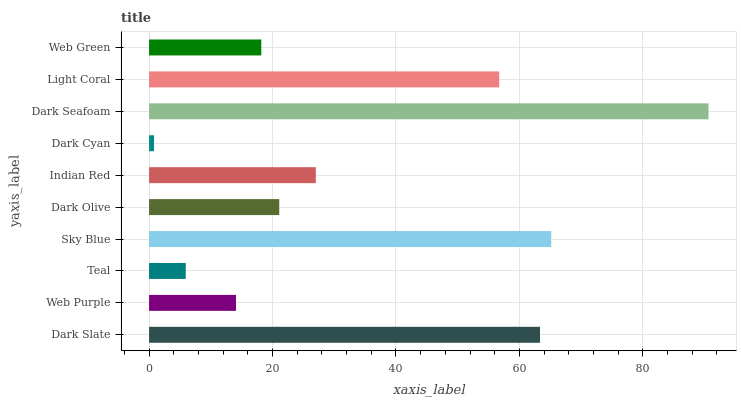Is Dark Cyan the minimum?
Answer yes or no. Yes. Is Dark Seafoam the maximum?
Answer yes or no. Yes. Is Web Purple the minimum?
Answer yes or no. No. Is Web Purple the maximum?
Answer yes or no. No. Is Dark Slate greater than Web Purple?
Answer yes or no. Yes. Is Web Purple less than Dark Slate?
Answer yes or no. Yes. Is Web Purple greater than Dark Slate?
Answer yes or no. No. Is Dark Slate less than Web Purple?
Answer yes or no. No. Is Indian Red the high median?
Answer yes or no. Yes. Is Dark Olive the low median?
Answer yes or no. Yes. Is Web Purple the high median?
Answer yes or no. No. Is Web Purple the low median?
Answer yes or no. No. 